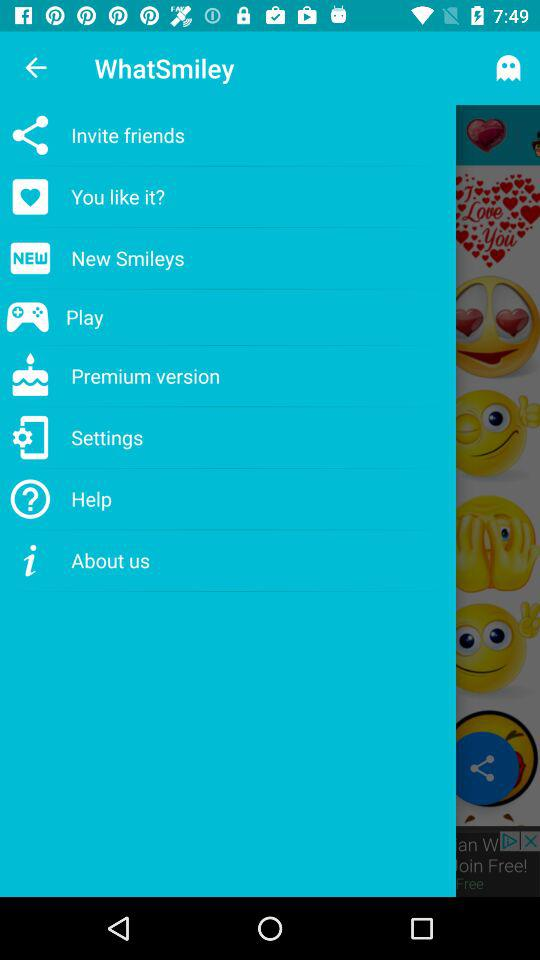What is the application name? The application name is "WhatSmiley". 